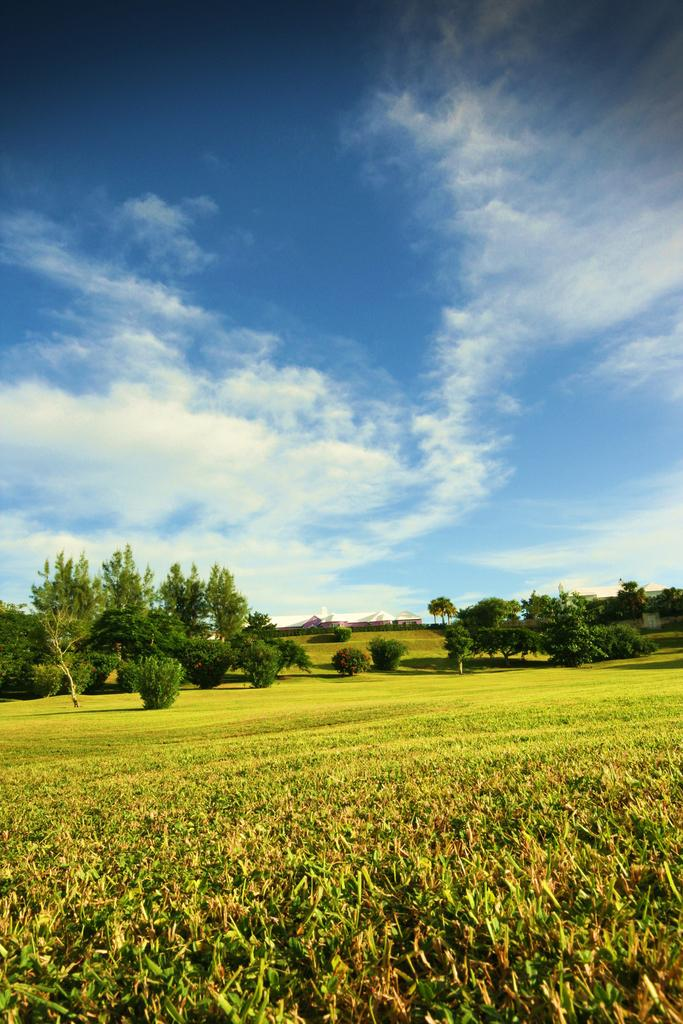What type of vegetation can be seen in the background of the image? There are many trees in the background of the image. Where are the trees located? The trees are on a grassland. What can be seen above the trees in the image? The sky is visible in the image. What is present in the sky? Clouds are present in the sky. What type of waste is being cleaned up by the carpenter in the image? There is no carpenter or waste present in the image. What tool is the carpenter using to cut the scissors in the image? There is no carpenter, scissors, or cutting activity in the image. 